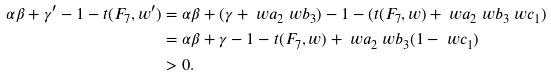<formula> <loc_0><loc_0><loc_500><loc_500>\alpha \beta + \gamma ^ { \prime } - 1 - t ( F _ { 7 } , w ^ { \prime } ) & = \alpha \beta + ( \gamma + \ w a _ { 2 } \ w b _ { 3 } ) - 1 - ( t ( F _ { 7 } , w ) + \ w a _ { 2 } \ w b _ { 3 } \ w c _ { 1 } ) \\ & = \alpha \beta + \gamma - 1 - t ( F _ { 7 } , w ) + \ w a _ { 2 } \ w b _ { 3 } ( 1 - \ w c _ { 1 } ) \\ & > 0 .</formula> 